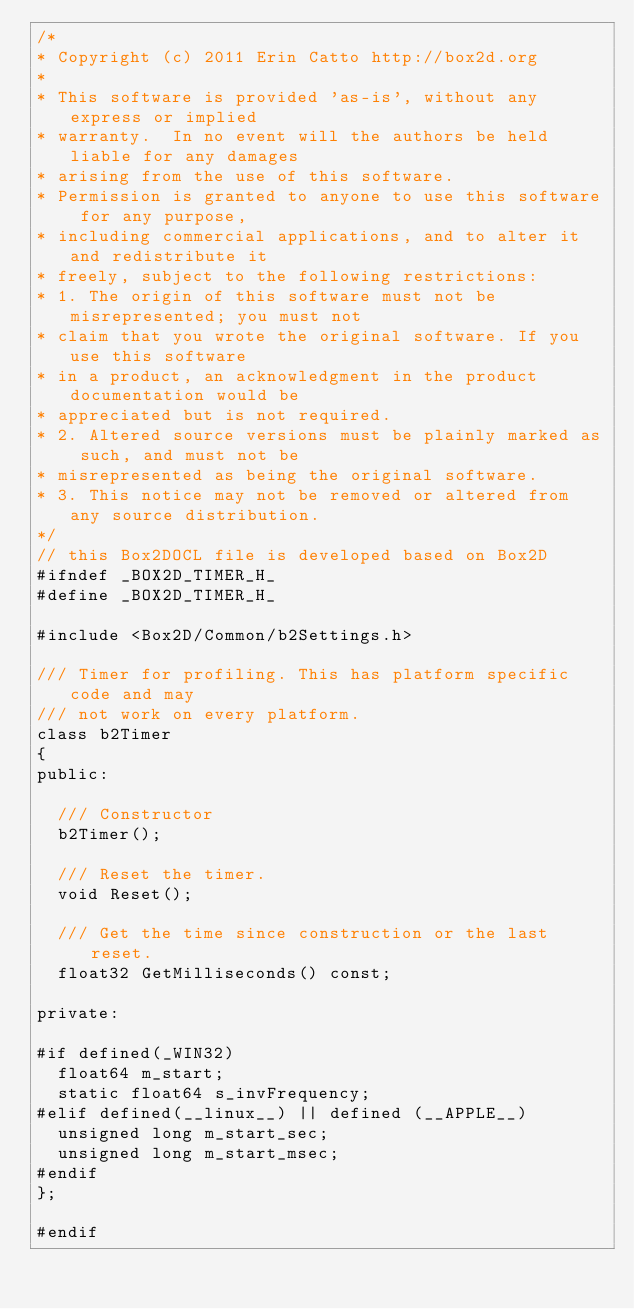<code> <loc_0><loc_0><loc_500><loc_500><_C_>/*
* Copyright (c) 2011 Erin Catto http://box2d.org
*
* This software is provided 'as-is', without any express or implied
* warranty.  In no event will the authors be held liable for any damages
* arising from the use of this software.
* Permission is granted to anyone to use this software for any purpose,
* including commercial applications, and to alter it and redistribute it
* freely, subject to the following restrictions:
* 1. The origin of this software must not be misrepresented; you must not
* claim that you wrote the original software. If you use this software
* in a product, an acknowledgment in the product documentation would be
* appreciated but is not required.
* 2. Altered source versions must be plainly marked as such, and must not be
* misrepresented as being the original software.
* 3. This notice may not be removed or altered from any source distribution.
*/
// this Box2DOCL file is developed based on Box2D
#ifndef _BOX2D_TIMER_H_
#define _BOX2D_TIMER_H_

#include <Box2D/Common/b2Settings.h>

/// Timer for profiling. This has platform specific code and may
/// not work on every platform.
class b2Timer
{
public:

	/// Constructor
	b2Timer();

	/// Reset the timer.
	void Reset();

	/// Get the time since construction or the last reset.
	float32 GetMilliseconds() const;

private:

#if defined(_WIN32)
	float64 m_start;
	static float64 s_invFrequency;
#elif defined(__linux__) || defined (__APPLE__)
	unsigned long m_start_sec;
	unsigned long m_start_msec;
#endif
};

#endif</code> 